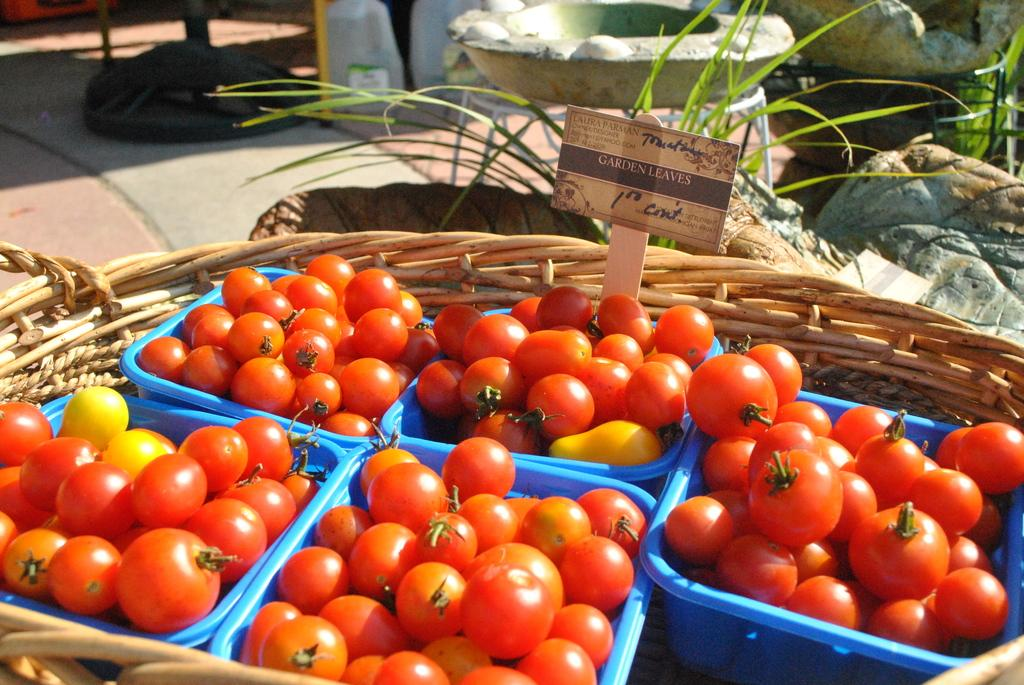How many blue baskets are in the image? There are five blue baskets in the image. What are the blue baskets containing? The blue baskets contain tomatoes. How are the blue baskets arranged in the image? The blue baskets are placed in a big basket. What type of natural environment is visible in the image? There is grass visible in the image. What type of inanimate objects can be seen in the image? There are rocks in the image. What might be the location of the image based on the possible contents? The image might have been taken in a market, as it contains baskets and produce. What type of cake is being played on the guitar in the image? There is no cake or guitar present in the image. 